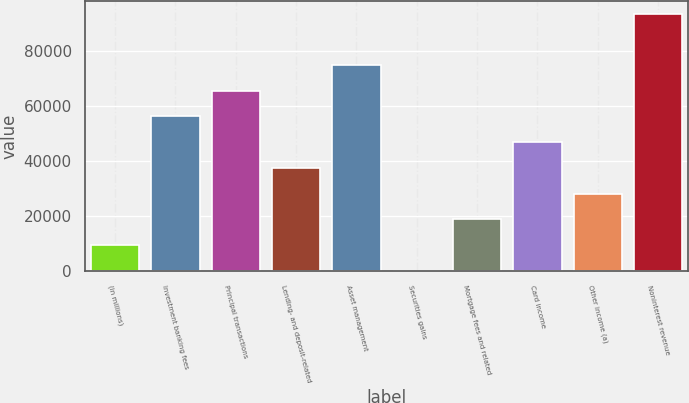Convert chart to OTSL. <chart><loc_0><loc_0><loc_500><loc_500><bar_chart><fcel>(in millions)<fcel>Investment banking fees<fcel>Principal transactions<fcel>Lending- and deposit-related<fcel>Asset management<fcel>Securities gains<fcel>Mortgage fees and related<fcel>Card income<fcel>Other income (a)<fcel>Noninterest revenue<nl><fcel>9536.1<fcel>56206.6<fcel>65540.7<fcel>37538.4<fcel>74874.8<fcel>202<fcel>18870.2<fcel>46872.5<fcel>28204.3<fcel>93543<nl></chart> 